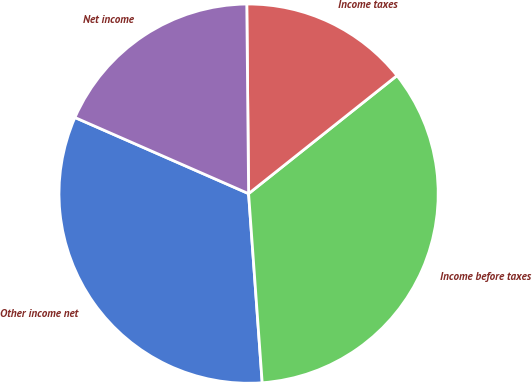Convert chart to OTSL. <chart><loc_0><loc_0><loc_500><loc_500><pie_chart><fcel>Other income net<fcel>Income before taxes<fcel>Income taxes<fcel>Net income<nl><fcel>32.72%<fcel>34.55%<fcel>14.46%<fcel>18.27%<nl></chart> 